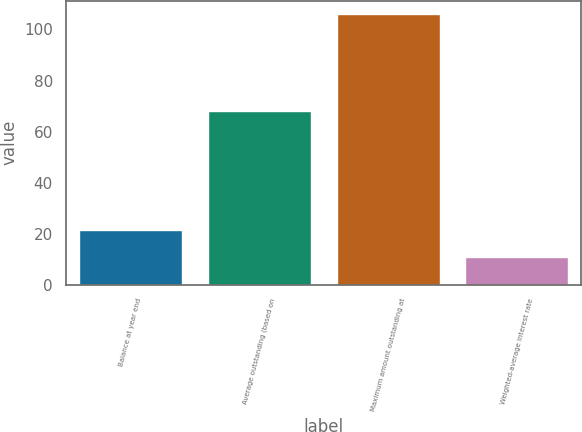Convert chart. <chart><loc_0><loc_0><loc_500><loc_500><bar_chart><fcel>Balance at year end<fcel>Average outstanding (based on<fcel>Maximum amount outstanding at<fcel>Weighted-average interest rate<nl><fcel>21.28<fcel>68<fcel>106<fcel>10.69<nl></chart> 